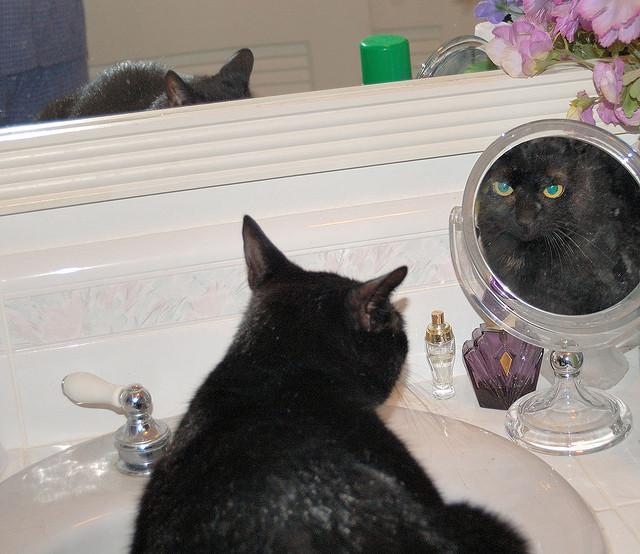How many cats are in the picture?
Give a very brief answer. 3. 